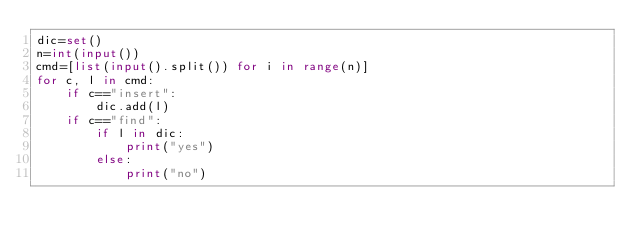Convert code to text. <code><loc_0><loc_0><loc_500><loc_500><_Python_>dic=set()
n=int(input())
cmd=[list(input().split()) for i in range(n)]
for c, l in cmd:
    if c=="insert":
        dic.add(l)
    if c=="find":
        if l in dic:
            print("yes")
        else:
            print("no")</code> 